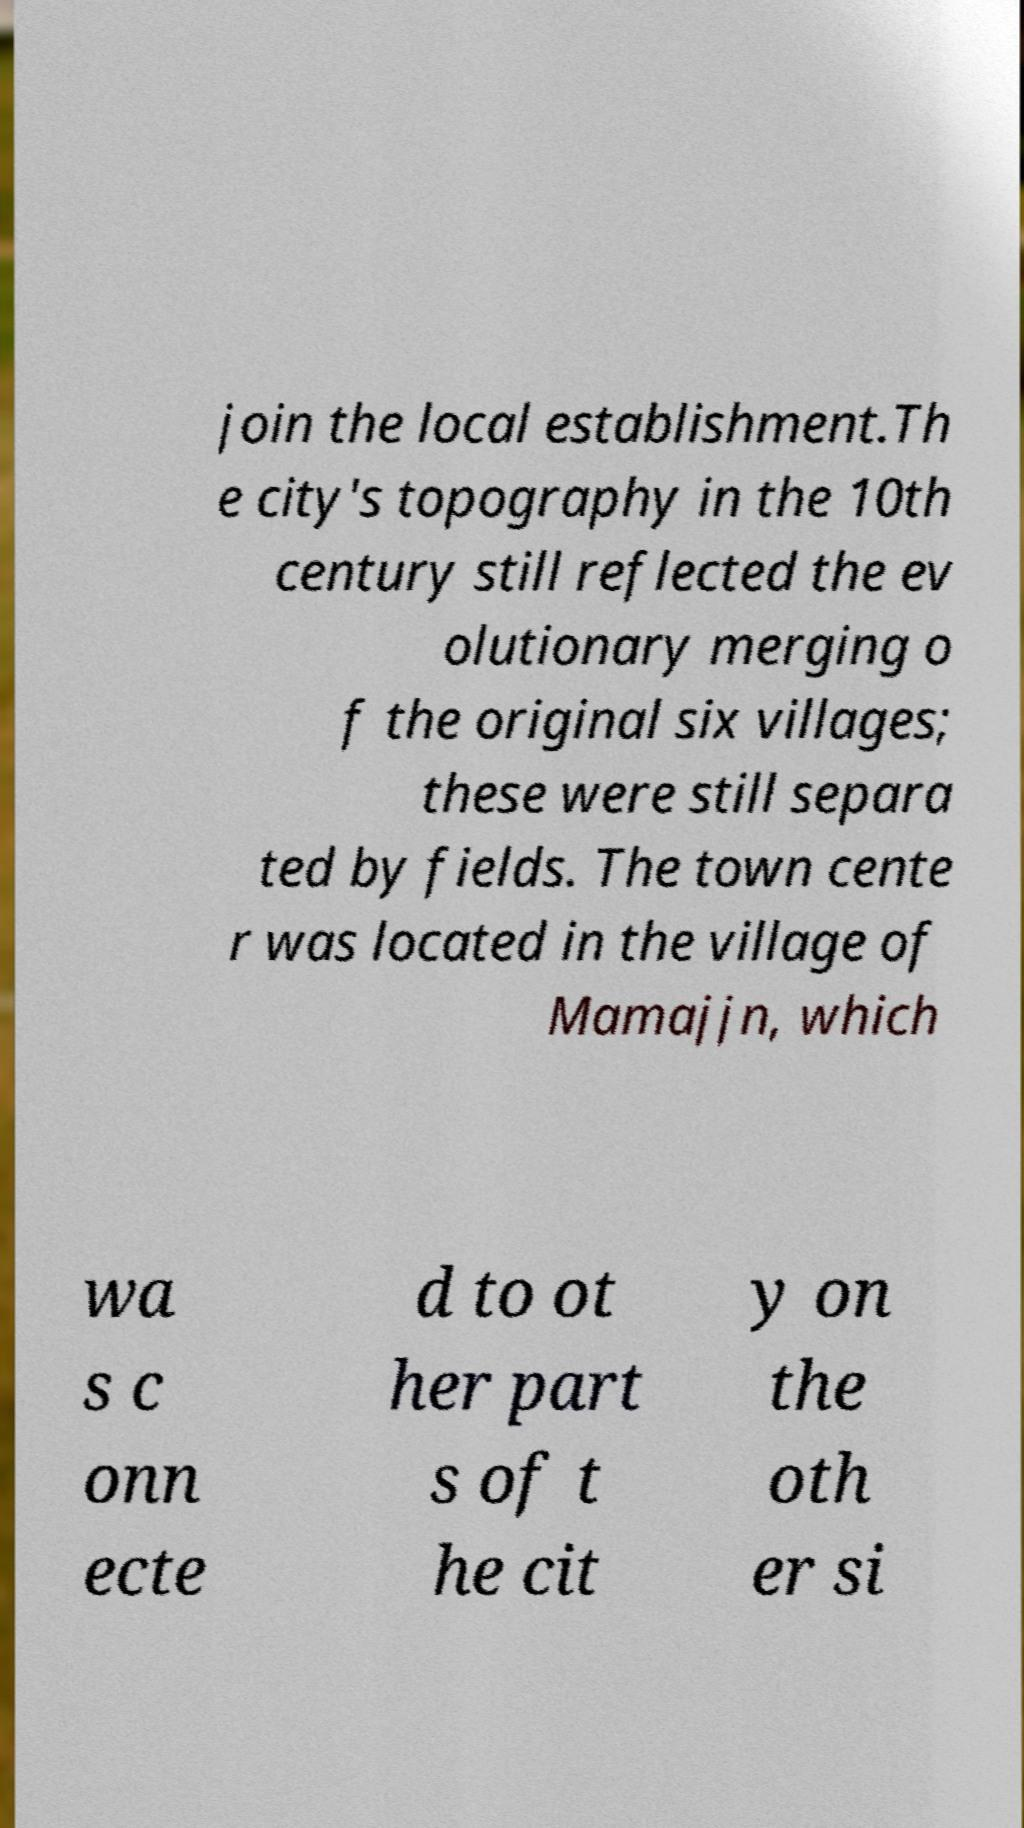I need the written content from this picture converted into text. Can you do that? join the local establishment.Th e city's topography in the 10th century still reflected the ev olutionary merging o f the original six villages; these were still separa ted by fields. The town cente r was located in the village of Mamajjn, which wa s c onn ecte d to ot her part s of t he cit y on the oth er si 